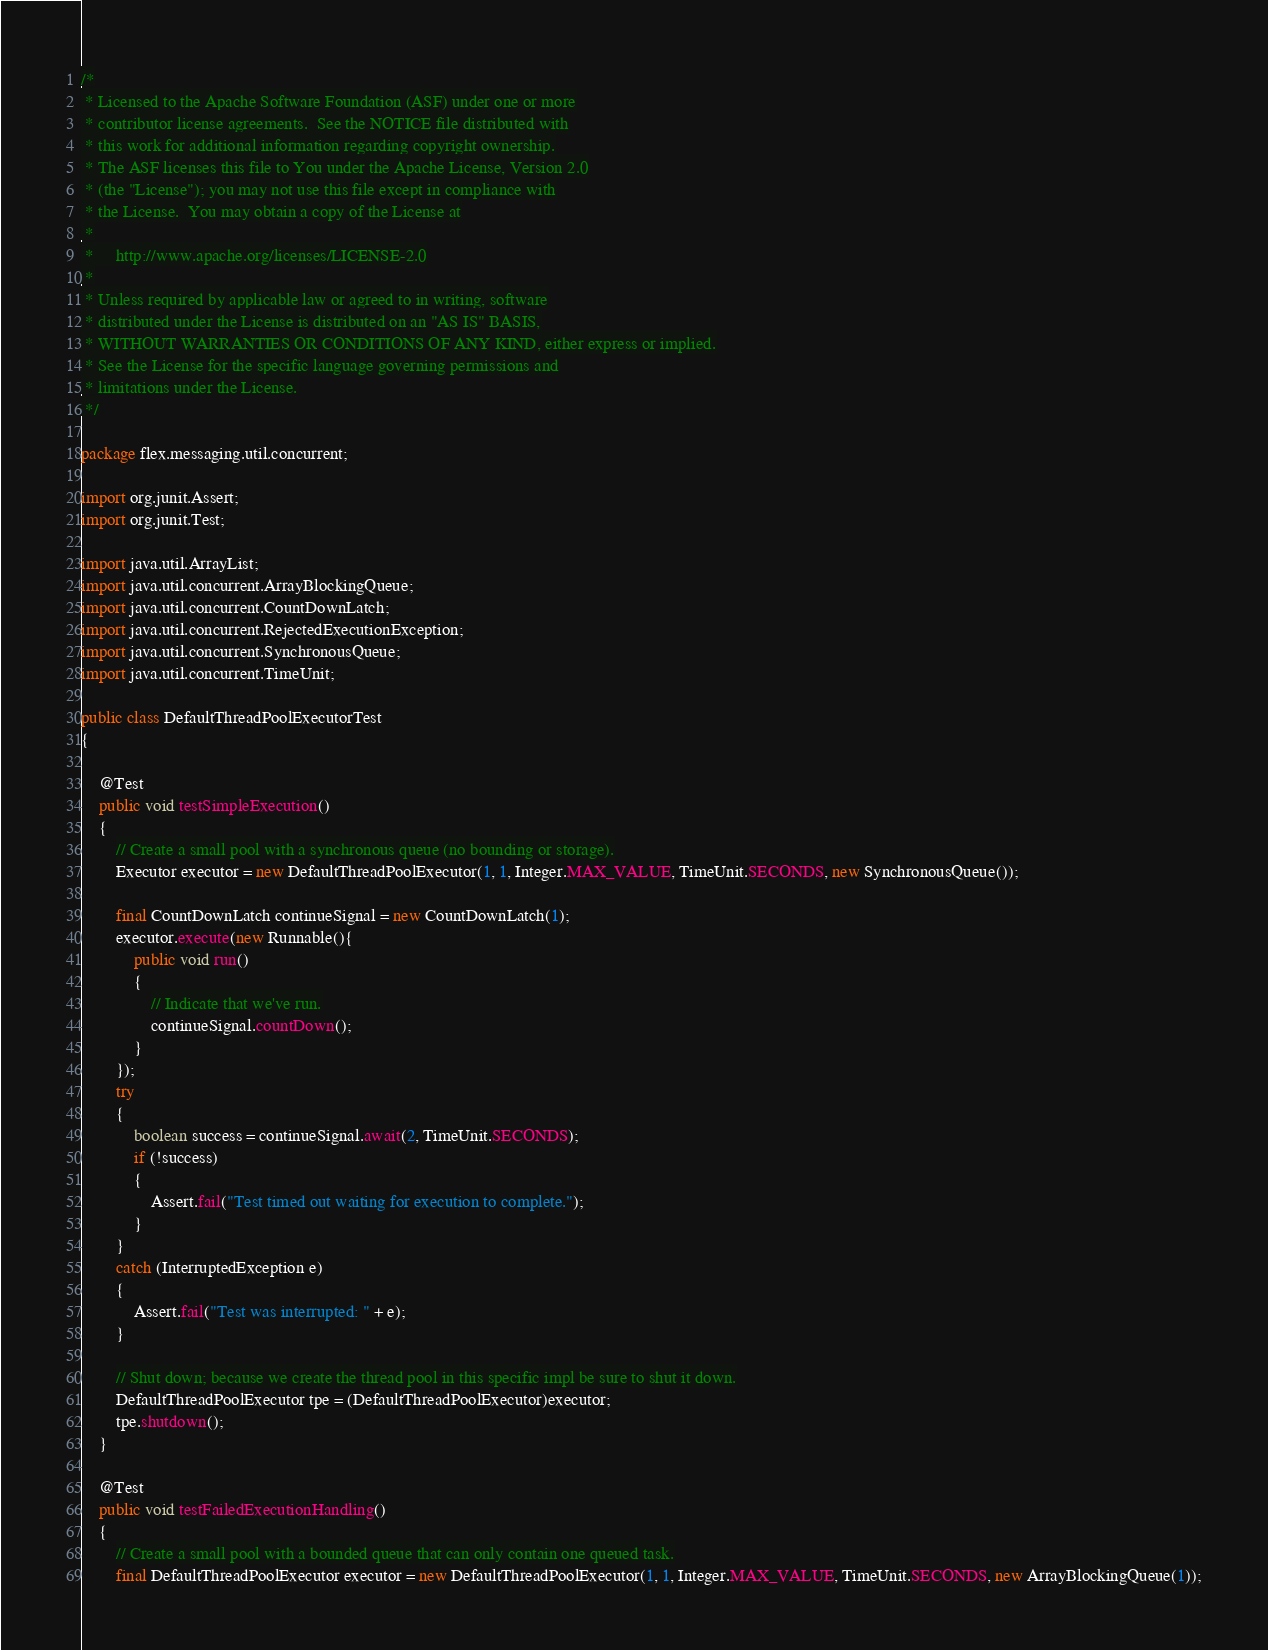<code> <loc_0><loc_0><loc_500><loc_500><_Java_>/*
 * Licensed to the Apache Software Foundation (ASF) under one or more
 * contributor license agreements.  See the NOTICE file distributed with
 * this work for additional information regarding copyright ownership.
 * The ASF licenses this file to You under the Apache License, Version 2.0
 * (the "License"); you may not use this file except in compliance with
 * the License.  You may obtain a copy of the License at
 *
 *     http://www.apache.org/licenses/LICENSE-2.0
 *
 * Unless required by applicable law or agreed to in writing, software
 * distributed under the License is distributed on an "AS IS" BASIS,
 * WITHOUT WARRANTIES OR CONDITIONS OF ANY KIND, either express or implied.
 * See the License for the specific language governing permissions and
 * limitations under the License.
 */

package flex.messaging.util.concurrent;

import org.junit.Assert;
import org.junit.Test;

import java.util.ArrayList;
import java.util.concurrent.ArrayBlockingQueue;
import java.util.concurrent.CountDownLatch;
import java.util.concurrent.RejectedExecutionException;
import java.util.concurrent.SynchronousQueue;
import java.util.concurrent.TimeUnit;

public class DefaultThreadPoolExecutorTest
{

    @Test
    public void testSimpleExecution()
    {
        // Create a small pool with a synchronous queue (no bounding or storage).
        Executor executor = new DefaultThreadPoolExecutor(1, 1, Integer.MAX_VALUE, TimeUnit.SECONDS, new SynchronousQueue());
                
        final CountDownLatch continueSignal = new CountDownLatch(1);
        executor.execute(new Runnable(){
            public void run()
            {
                // Indicate that we've run.
                continueSignal.countDown();
            }
        });
        try
        {
            boolean success = continueSignal.await(2, TimeUnit.SECONDS);
            if (!success)
            {
                Assert.fail("Test timed out waiting for execution to complete.");
            }
        }
        catch (InterruptedException e)
        {
            Assert.fail("Test was interrupted: " + e);
        }
        
        // Shut down; because we create the thread pool in this specific impl be sure to shut it down.
        DefaultThreadPoolExecutor tpe = (DefaultThreadPoolExecutor)executor;
        tpe.shutdown();
    }

    @Test
    public void testFailedExecutionHandling()
    {
        // Create a small pool with a bounded queue that can only contain one queued task.
        final DefaultThreadPoolExecutor executor = new DefaultThreadPoolExecutor(1, 1, Integer.MAX_VALUE, TimeUnit.SECONDS, new ArrayBlockingQueue(1));</code> 